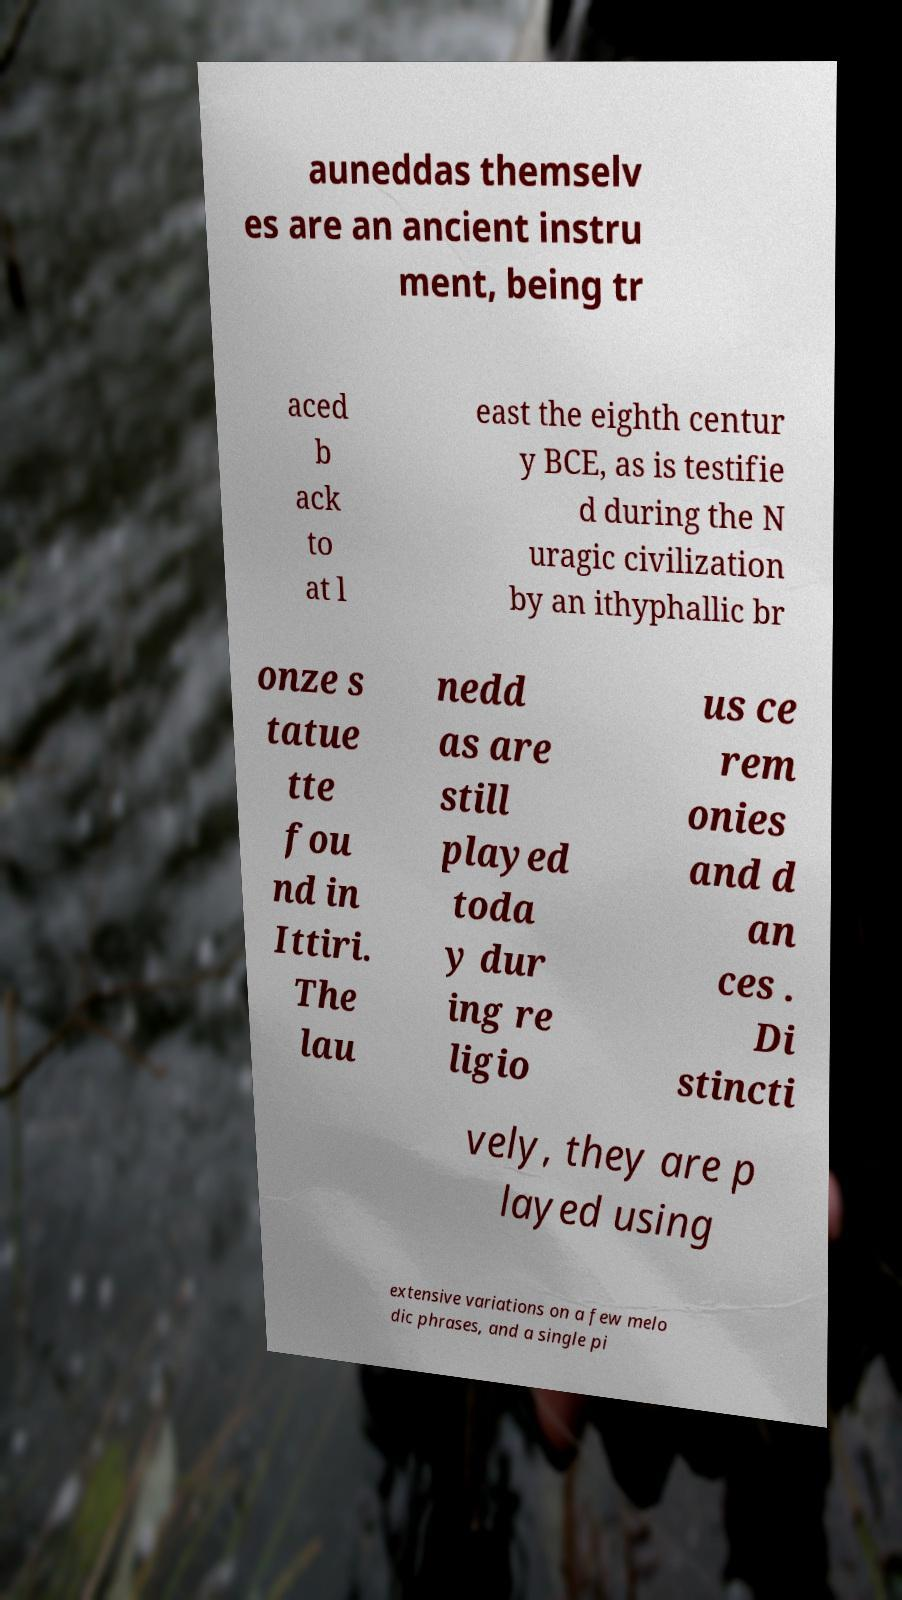Could you extract and type out the text from this image? auneddas themselv es are an ancient instru ment, being tr aced b ack to at l east the eighth centur y BCE, as is testifie d during the N uragic civilization by an ithyphallic br onze s tatue tte fou nd in Ittiri. The lau nedd as are still played toda y dur ing re ligio us ce rem onies and d an ces . Di stincti vely, they are p layed using extensive variations on a few melo dic phrases, and a single pi 